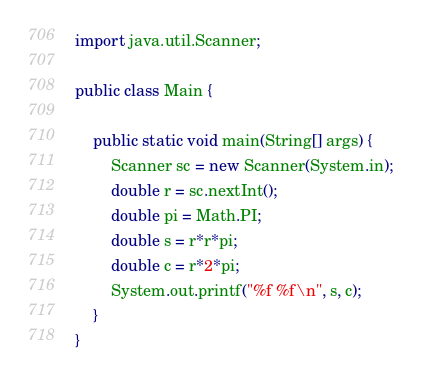<code> <loc_0><loc_0><loc_500><loc_500><_Java_>import java.util.Scanner;

public class Main {

    public static void main(String[] args) {
        Scanner sc = new Scanner(System.in);
        double r = sc.nextInt();
        double pi = Math.PI;
        double s = r*r*pi;
        double c = r*2*pi;
        System.out.printf("%f %f\n", s, c);
    }
}
</code> 